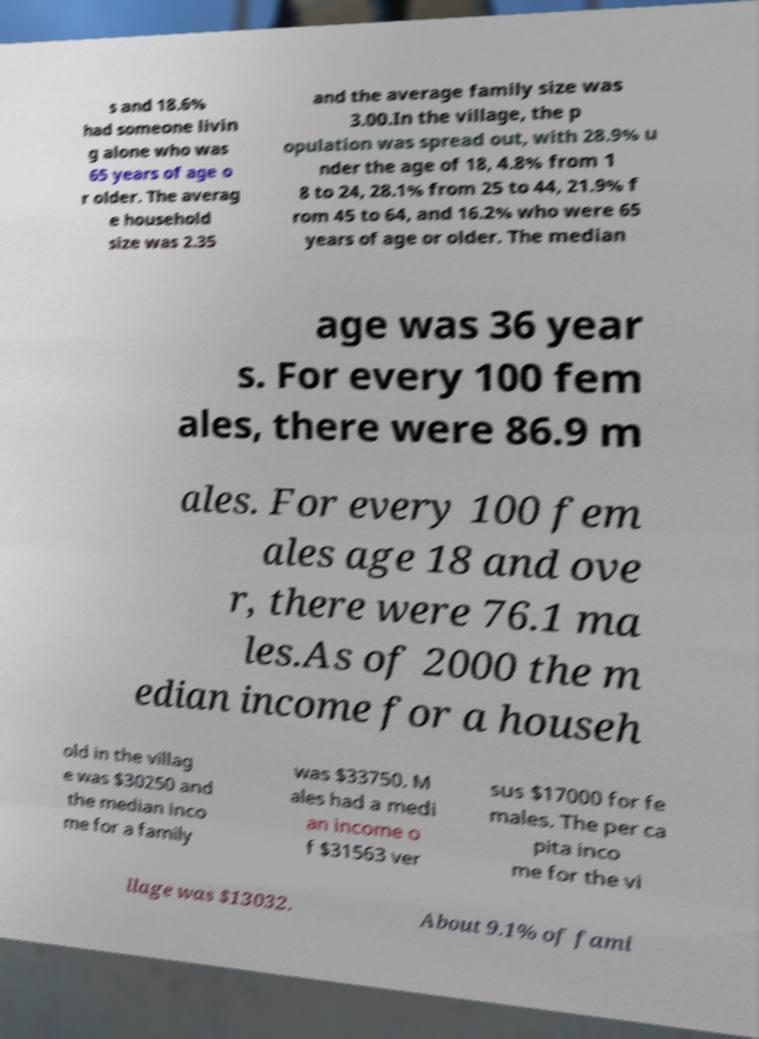Please identify and transcribe the text found in this image. s and 18.6% had someone livin g alone who was 65 years of age o r older. The averag e household size was 2.35 and the average family size was 3.00.In the village, the p opulation was spread out, with 28.9% u nder the age of 18, 4.8% from 1 8 to 24, 28.1% from 25 to 44, 21.9% f rom 45 to 64, and 16.2% who were 65 years of age or older. The median age was 36 year s. For every 100 fem ales, there were 86.9 m ales. For every 100 fem ales age 18 and ove r, there were 76.1 ma les.As of 2000 the m edian income for a househ old in the villag e was $30250 and the median inco me for a family was $33750. M ales had a medi an income o f $31563 ver sus $17000 for fe males. The per ca pita inco me for the vi llage was $13032. About 9.1% of fami 